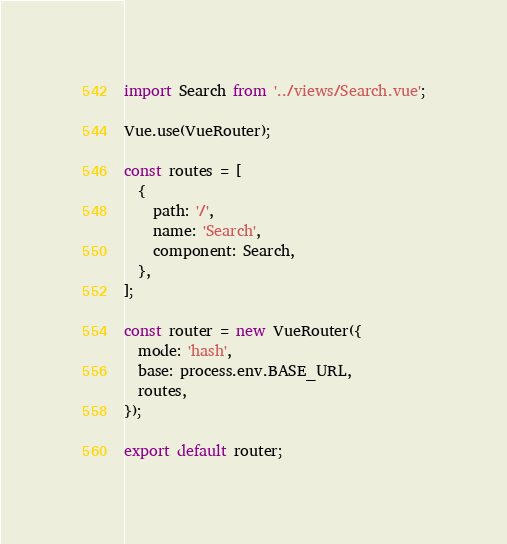Convert code to text. <code><loc_0><loc_0><loc_500><loc_500><_JavaScript_>import Search from '../views/Search.vue';

Vue.use(VueRouter);

const routes = [
  {
    path: '/',
    name: 'Search',
    component: Search,
  },
];

const router = new VueRouter({
  mode: 'hash',
  base: process.env.BASE_URL,
  routes,
});

export default router;
</code> 